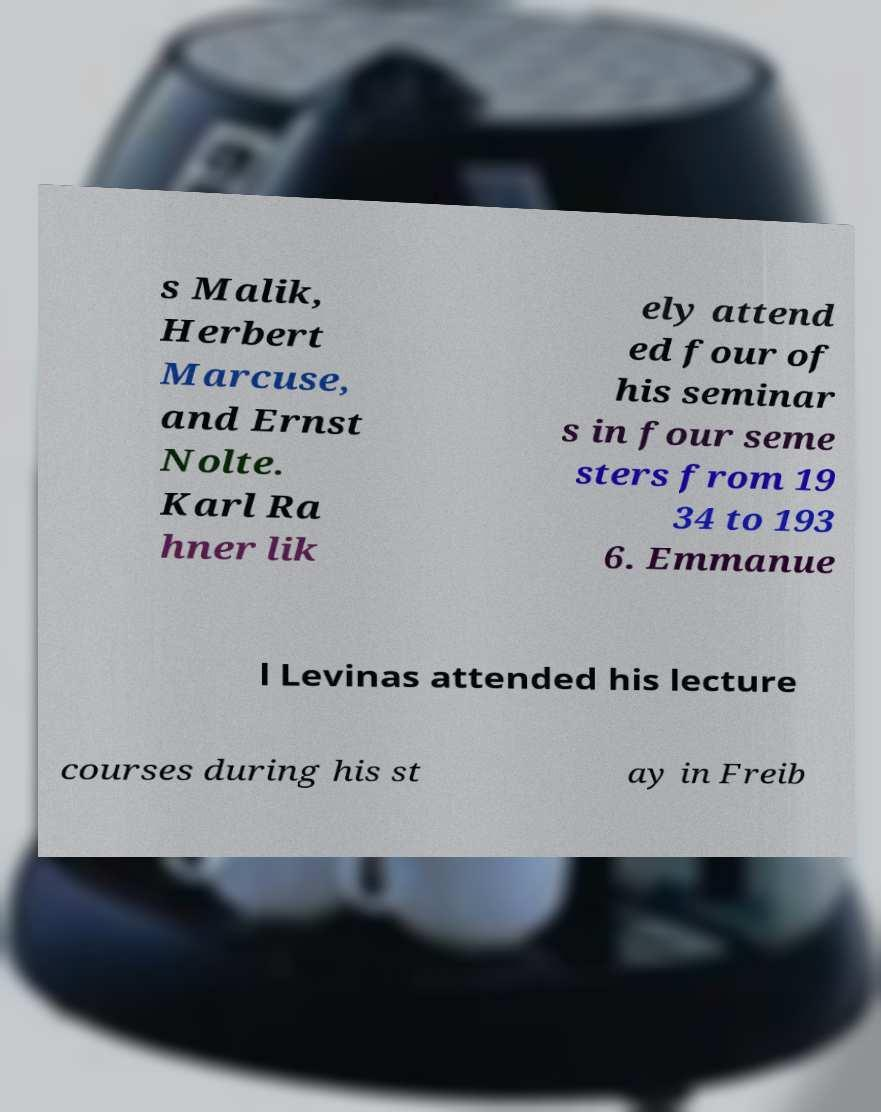Can you read and provide the text displayed in the image?This photo seems to have some interesting text. Can you extract and type it out for me? s Malik, Herbert Marcuse, and Ernst Nolte. Karl Ra hner lik ely attend ed four of his seminar s in four seme sters from 19 34 to 193 6. Emmanue l Levinas attended his lecture courses during his st ay in Freib 